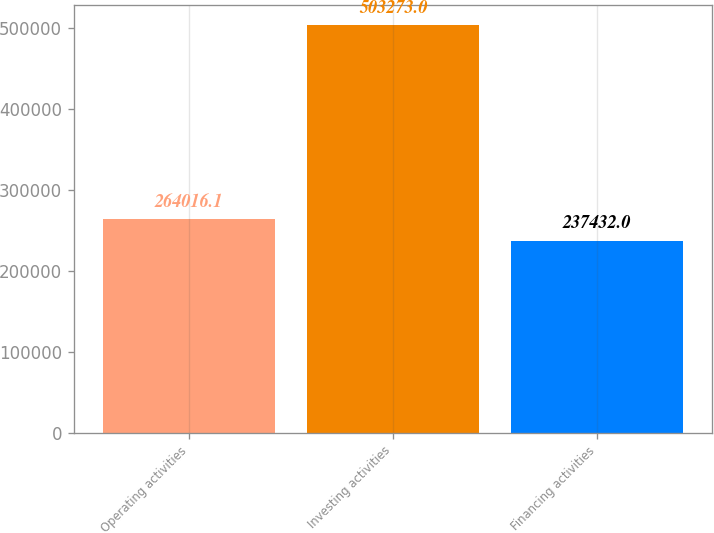Convert chart to OTSL. <chart><loc_0><loc_0><loc_500><loc_500><bar_chart><fcel>Operating activities<fcel>Investing activities<fcel>Financing activities<nl><fcel>264016<fcel>503273<fcel>237432<nl></chart> 